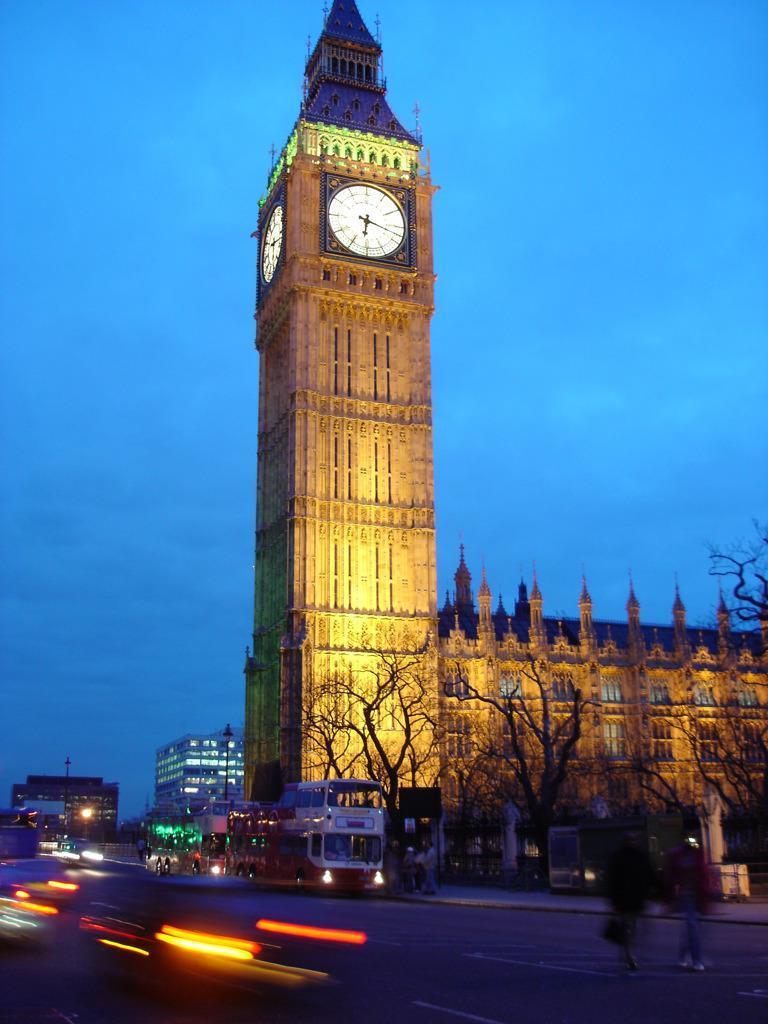Describe this image in one or two sentences. There are vehicles and people on the road. There are dry trees and buildings. A building has a clock on the top. 